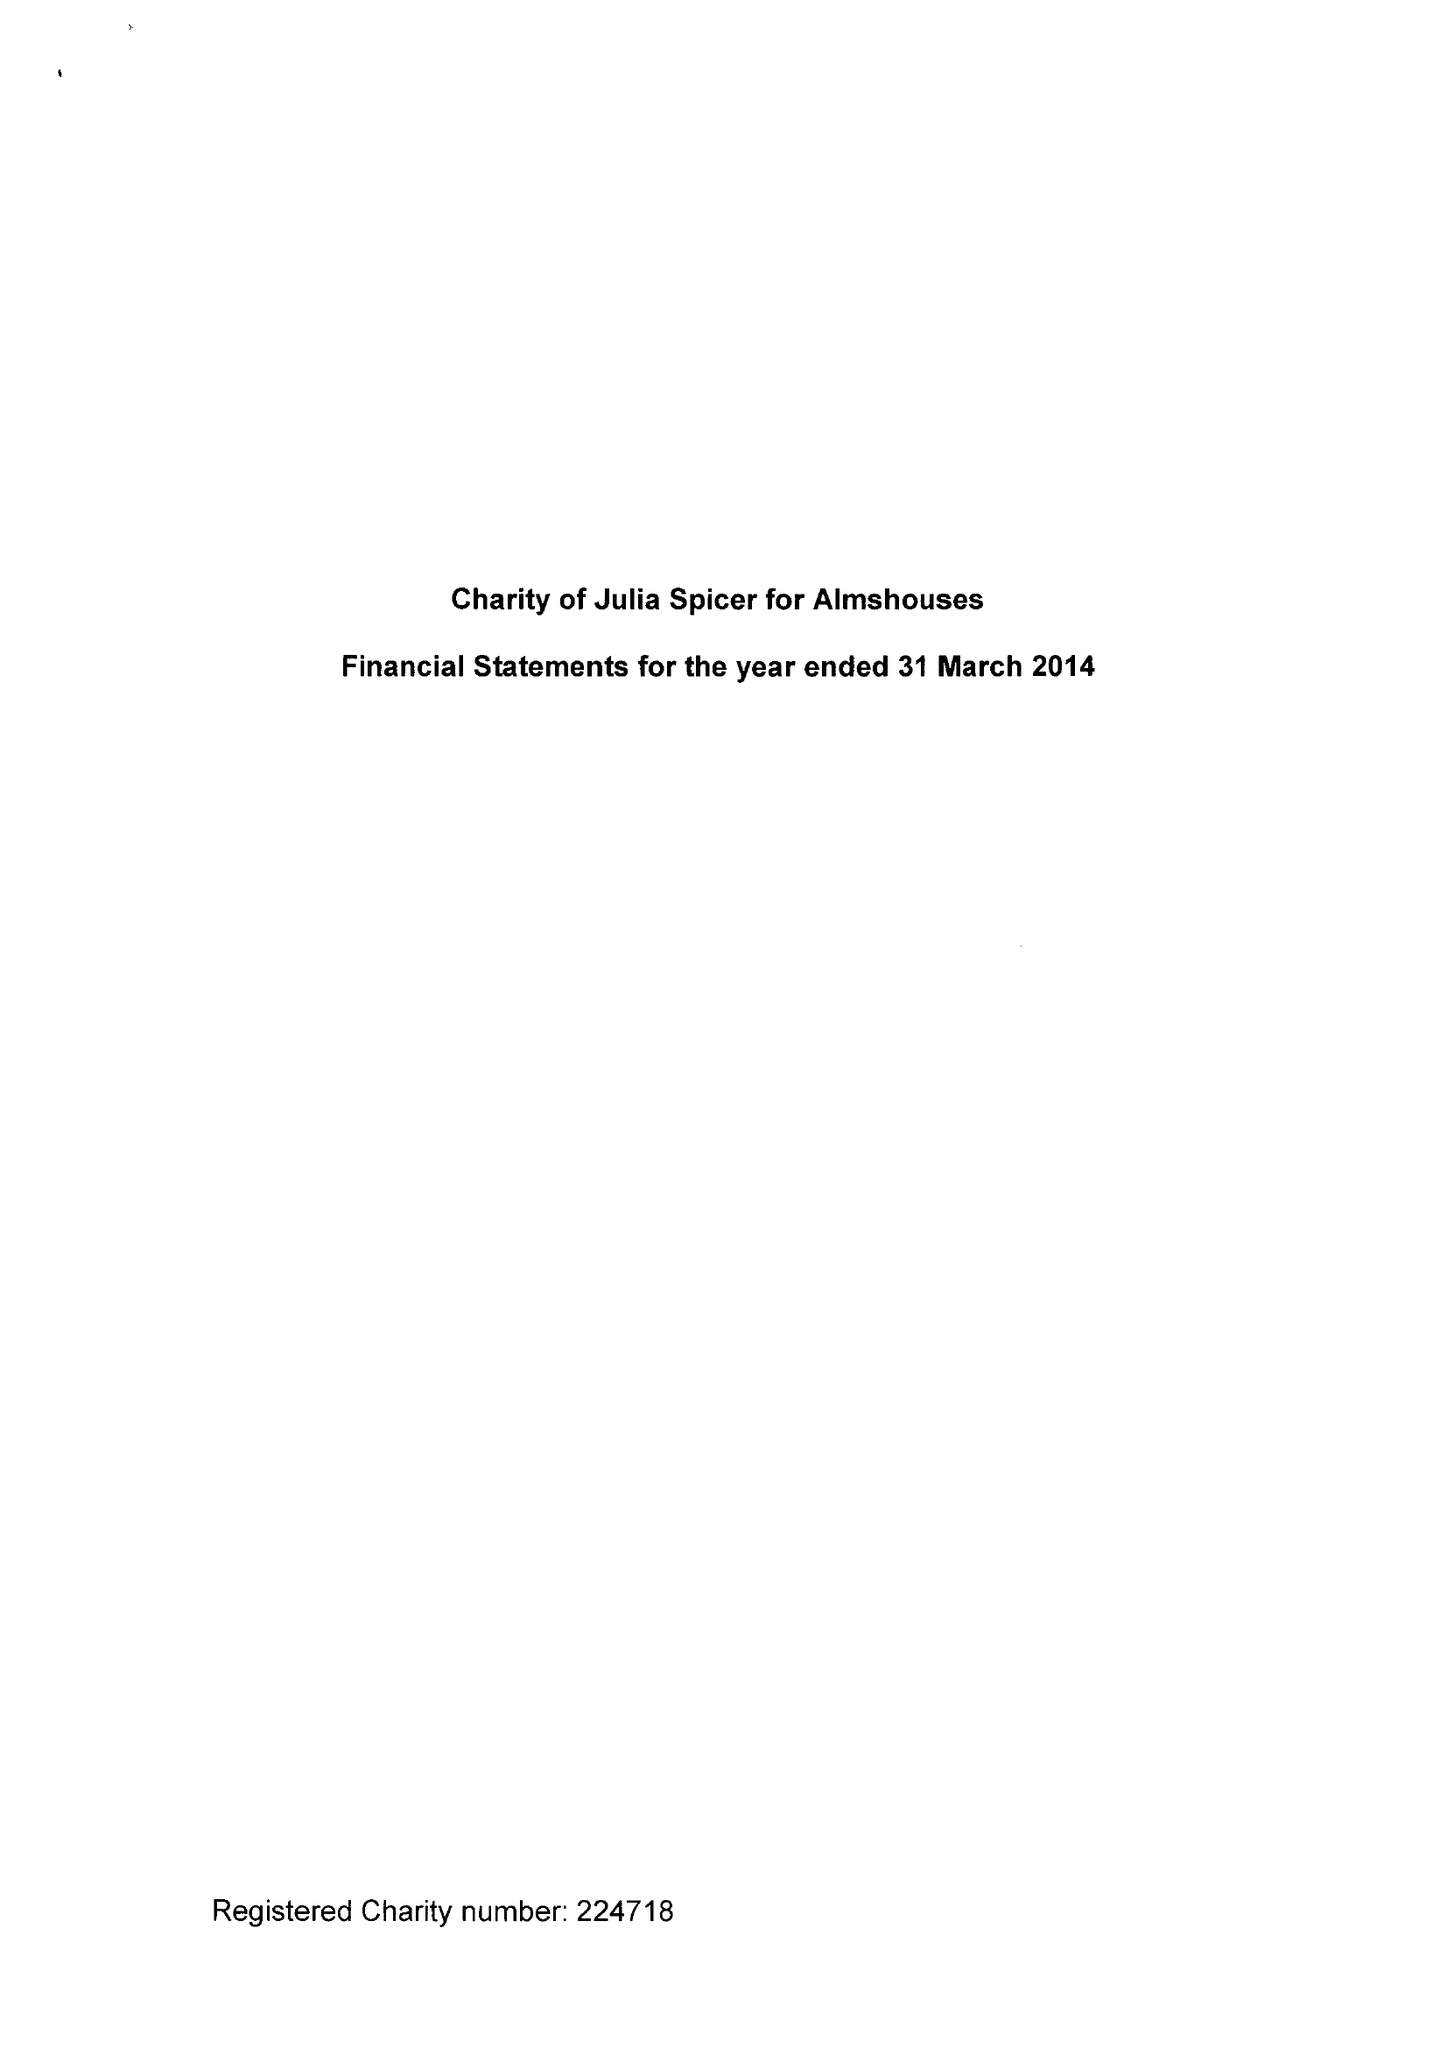What is the value for the spending_annually_in_british_pounds?
Answer the question using a single word or phrase. 22253.00 